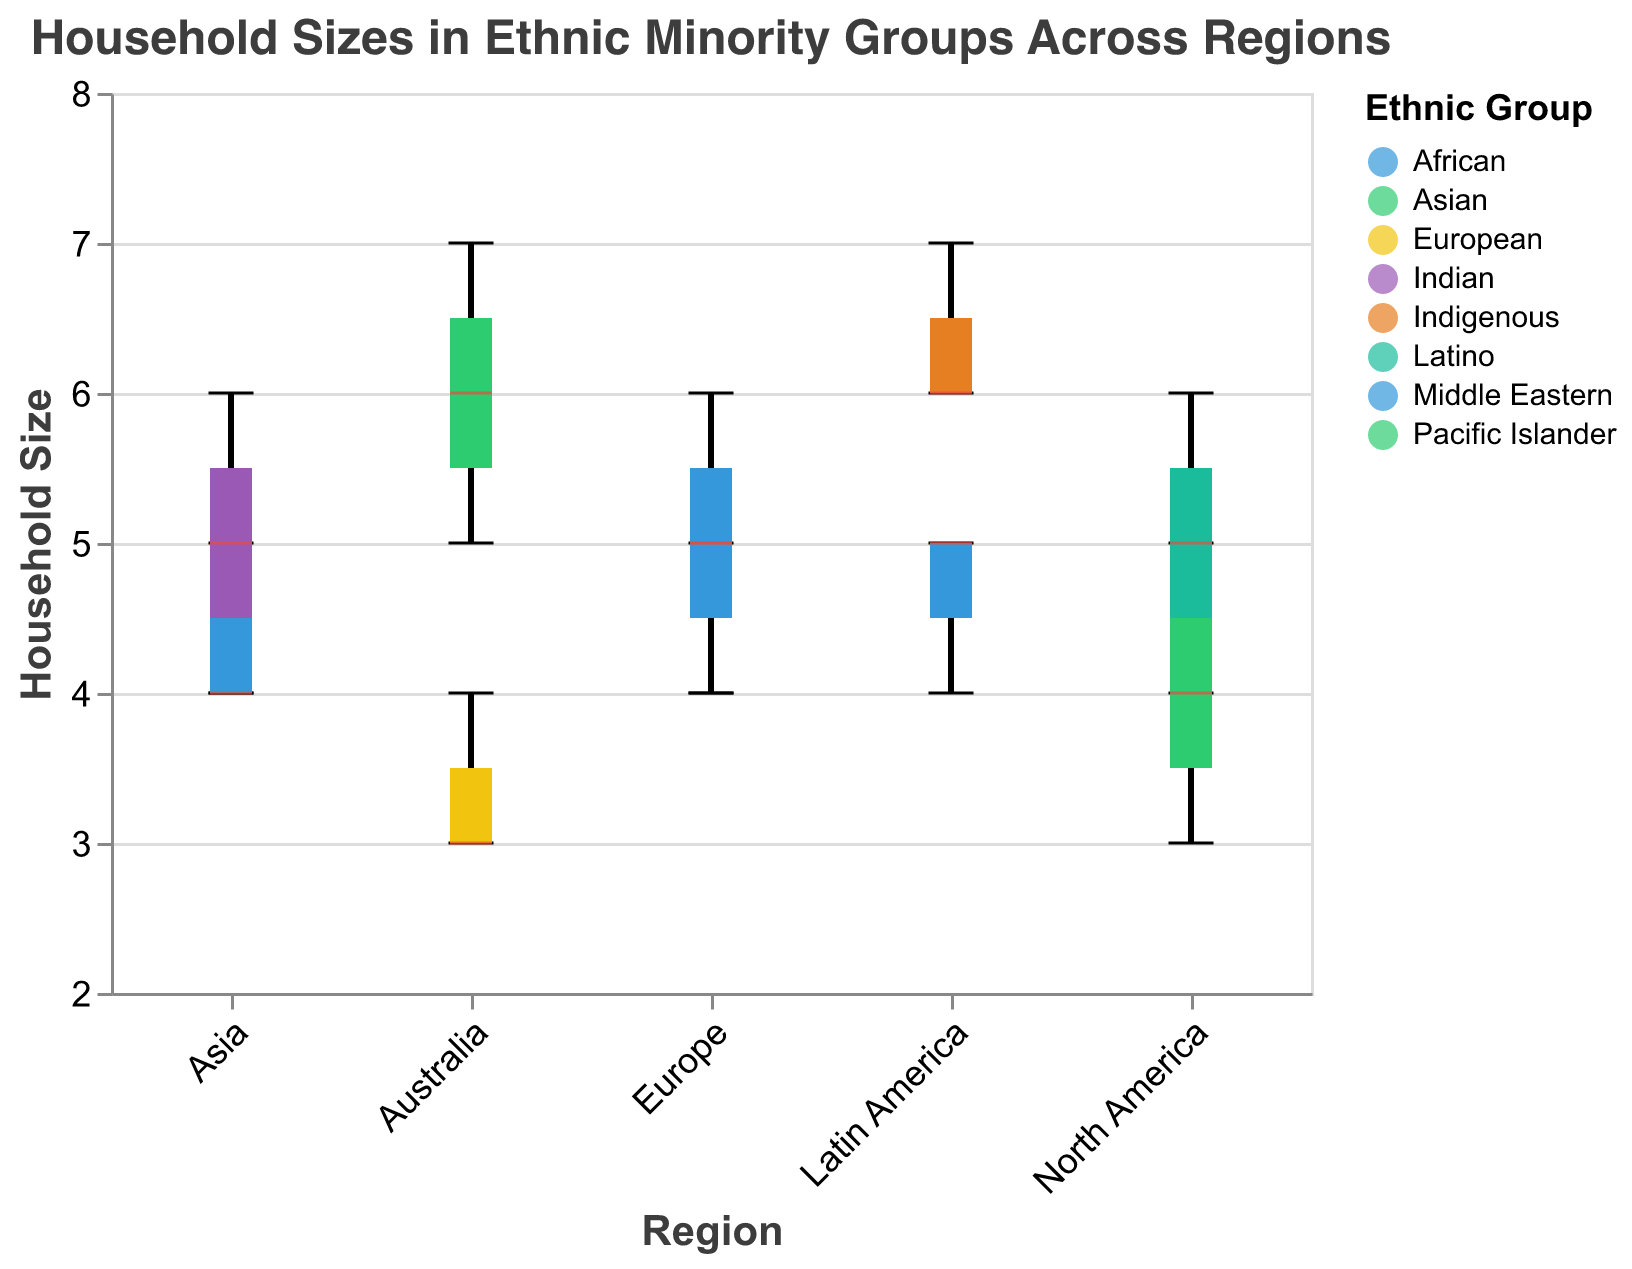What is the title of the figure? The title appears at the top of the figure, reading "Household Sizes in Ethnic Minority Groups Across Regions".
Answer: Household Sizes in Ethnic Minority Groups Across Regions What is the median household size for the Latino ethnic group in North America? The median is the line within the box for each group. For the Latino group in North America, the median household size is 5.
Answer: 5 Which ethnic group in Australia has the largest household size, and what is it? By looking at the maximum tick of the box plot for groups in Australia, the Pacific Islander group's maximum value is 7, which is the largest for that region.
Answer: Pacific Islander, 7 What region has the highest median household size for any ethnic group, and what is this median? The highest median can be found by comparing the median lines across all groups in each region. The Pacific Islander in Australia has the highest median at 6.
Answer: Australia, 6 Which regions have ethnic groups with a household size range (difference between max and min) of 3? To find this, subtract the smallest household size from the largest within each box plot. Both North America (Latino) and Europe (Middle Eastern) have ranges of 3 (6-4=2+1=3).
Answer: North America and Europe What is the interquartile range (IQR) for the African ethnic group in Europe? The IQR is the difference between the 1st and 3rd quartiles. Since the 1st quartile (bottom of the box) is 4 and the 3rd quartile (top of the box) is 5, the IQR is 5-4=1.
Answer: 1 Which ethnic group in Latin America has a more varied household size? To determine this, compare the heights of the boxes. The Indigenous group has a wider spread, indicating more variation.
Answer: Indigenous What is the mode household size for the African ethnic group in Latin America? Mode is the most frequent value. Observing the African group in Latin America, the frequent values are 4 and 5.
Answer: 4 and 5 Are there any ethnic groups with a household size of 7 in regions other than Australia? Checking visually across all box plots, only the Indigenous group in Latin America and the Pacific Islander group in Australia have a household size of 7.
Answer: Yes, in Latin America (Indigenous) Which region has the smallest range of household sizes for any ethnic group, and what is this range? By comparing the width of the boxes, African and Indian groups in Asia have the smallest range, and the difference between the maximum and minimum for these groups is only 1 (5-4=1).
Answer: Asia, 1 